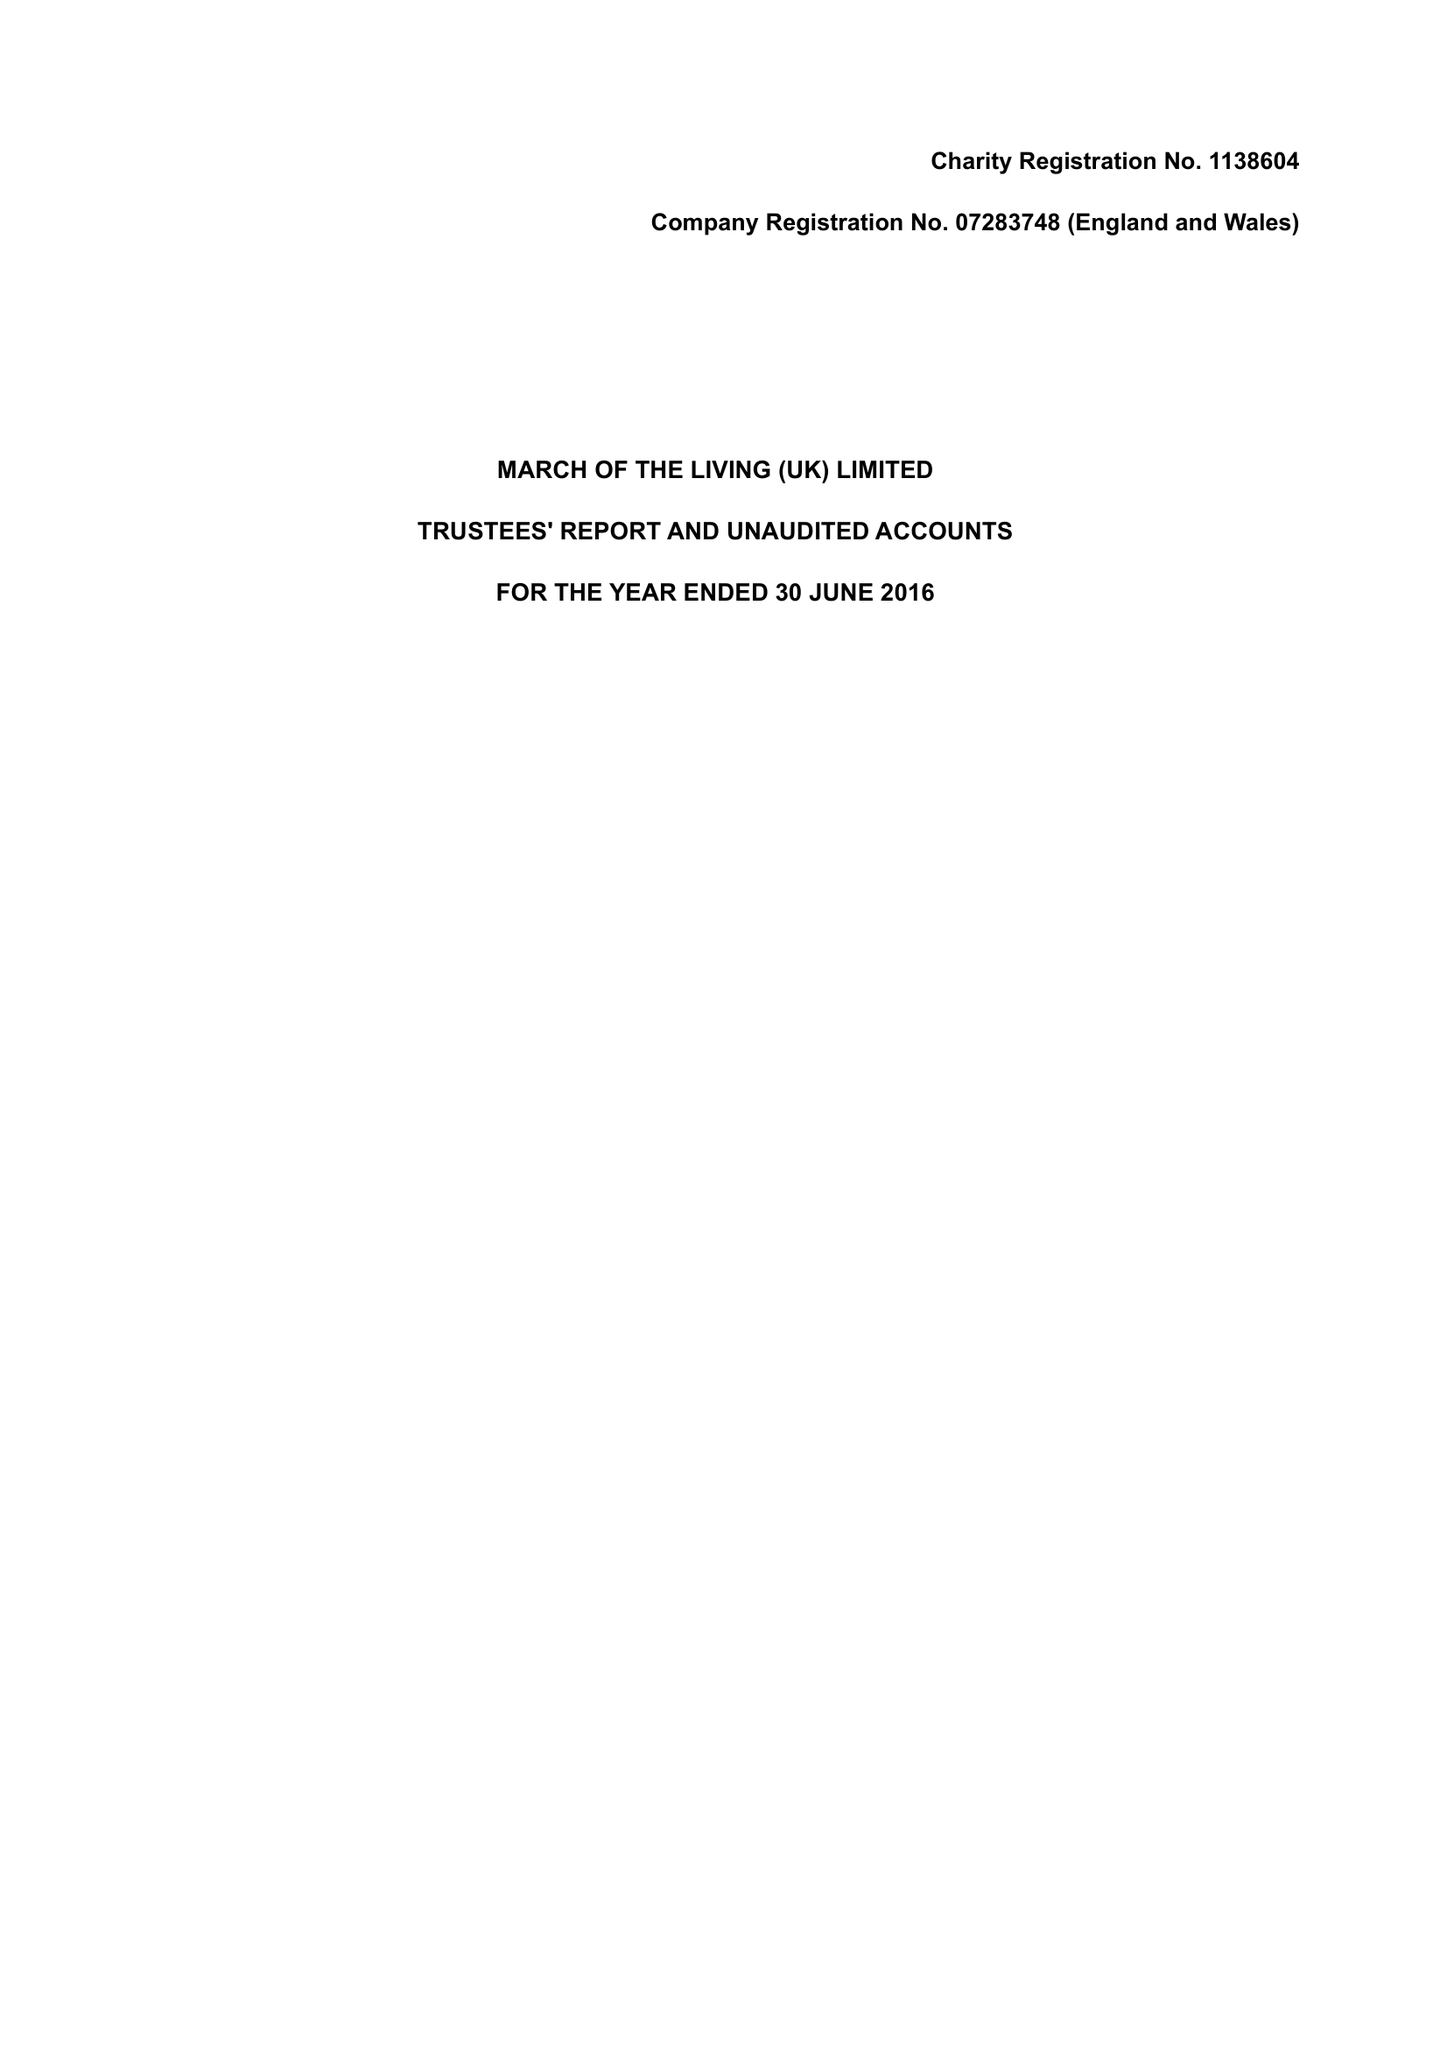What is the value for the address__street_line?
Answer the question using a single word or phrase. 1 BALLARDS LANE 